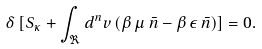<formula> <loc_0><loc_0><loc_500><loc_500>\delta \, [ S _ { \kappa } + \int _ { \Re } d ^ { n } v \, ( \beta \, \mu \, \bar { n } - \beta \, \epsilon \, \bar { n } ) ] = 0 .</formula> 